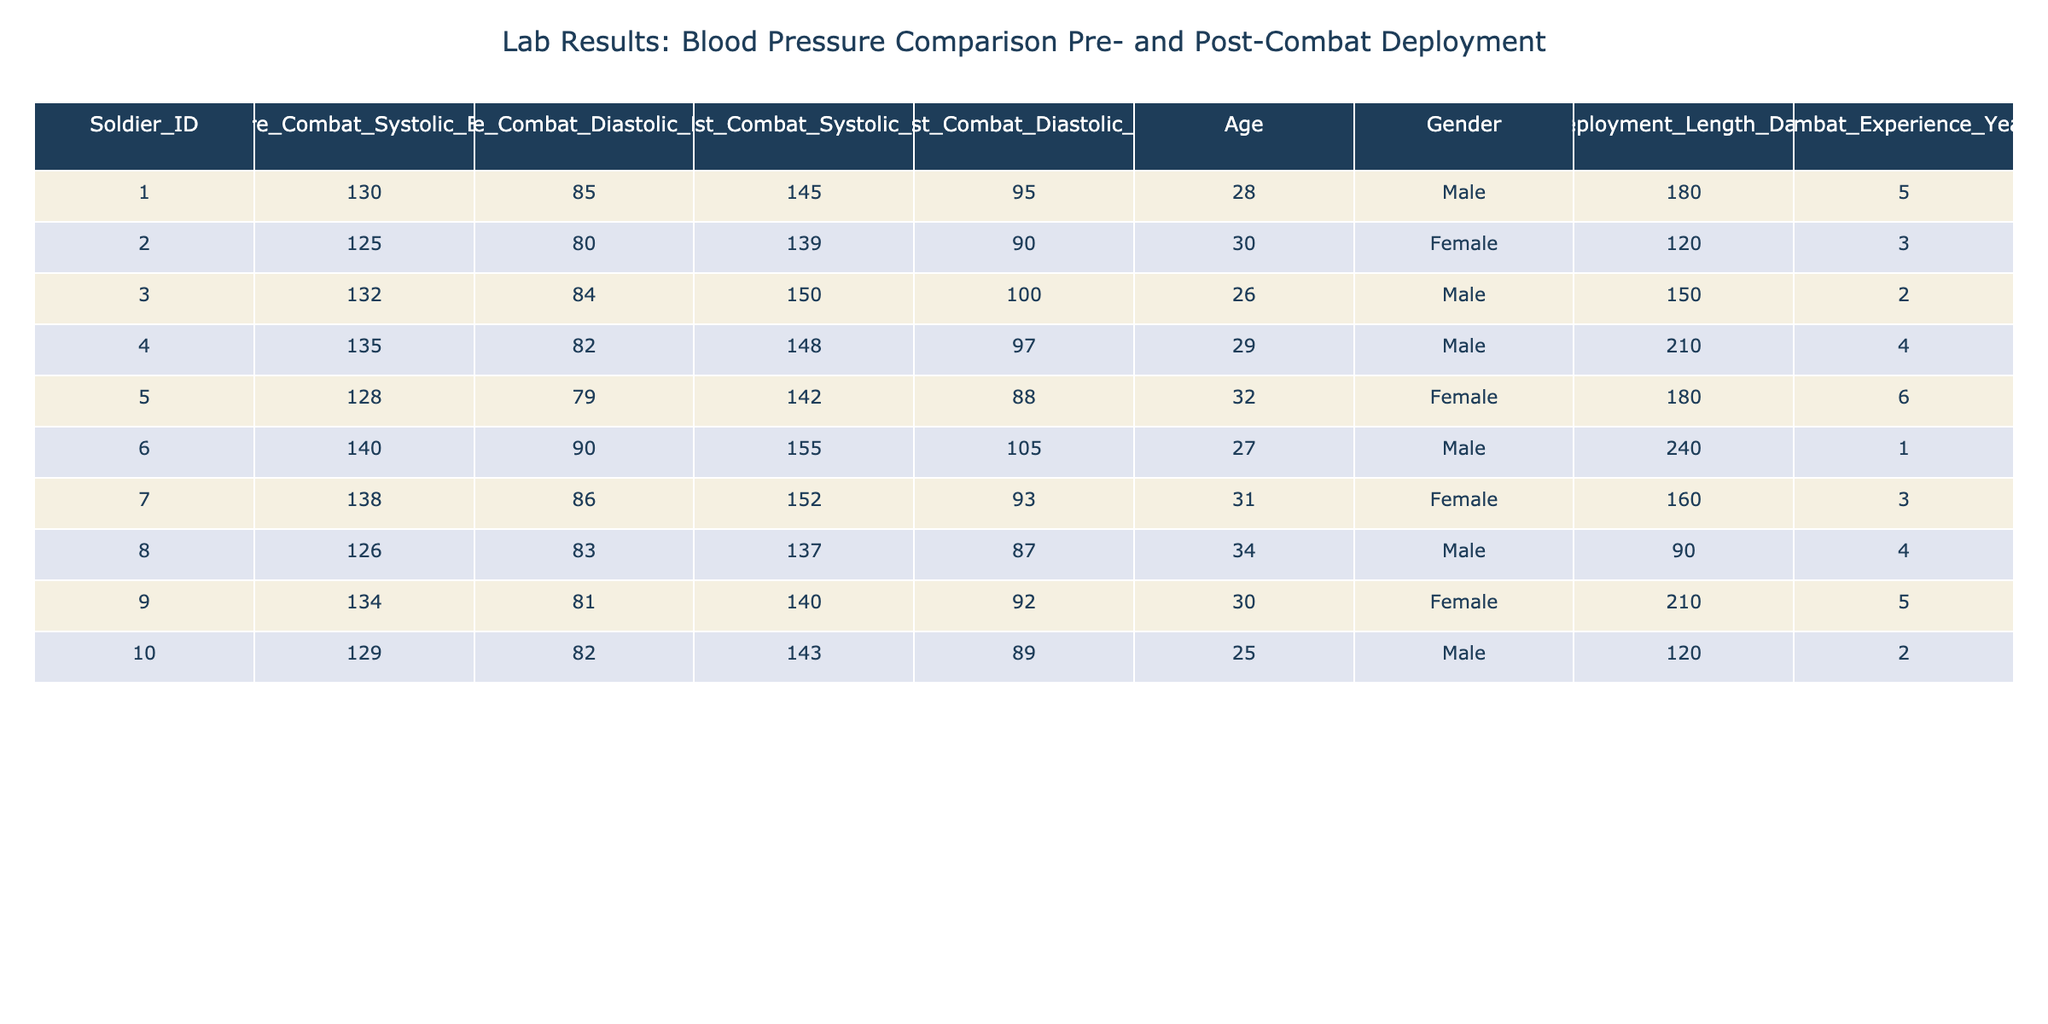What is the highest recorded post-combat systolic blood pressure? The highest post-combat systolic blood pressure can be found by checking each soldier's post-combat systolic blood pressure values. Looking through the table, Soldier 006 has a post-combat systolic blood pressure of 155, which is the highest among all soldiers listed.
Answer: 155 What is the average pre-combat diastolic blood pressure of female soldiers? To find the average pre-combat diastolic blood pressure for female soldiers, we take the values for females: 80, 88, 90 (from soldiers 002, 005, and 007). The sum is 80 + 88 + 90 = 258. There are 3 individuals, so we divide by 3: 258 / 3 = 86.
Answer: 86 Did any soldier have a higher diastolic blood pressure post-combat than pre-combat? We need to compare each soldier's pre-combat and post-combat diastolic blood pressure. Soldiers 001, 006, and 003 show higher post-combat diastolic blood pressures (95, 105, and 100 respectively) compared to pre-combat values (85, 90, and 84). Therefore, yes, some soldiers have a higher post-combat diastolic blood pressure.
Answer: Yes How many soldiers had systolic blood pressure below 135 pre-combat? We check the pre-combat systolic blood pressure values and count those below 135. Soldiers 002 (125), 008 (126), and 010 (129) all have systolic blood pressures below 135. This gives us a total of 3 soldiers.
Answer: 3 What is the difference in average post-combat diastolic blood pressure compared to pre-combat? First, we calculate the average post-combat diastolic blood pressure by adding all values: 95 + 90 + 100 + 97 + 88 + 105 + 93 + 87 + 92 + 89 = 936 for 10 soldiers, which gives an average of 936 / 10 = 93.6. For pre-combat, we sum: 85 + 80 + 84 + 82 + 79 + 90 + 86 + 83 + 81 + 82 = 834 for 10 soldiers, resulting in an average of 834 / 10 = 83.4. The difference is 93.6 - 83.4 = 10.2.
Answer: 10.2 